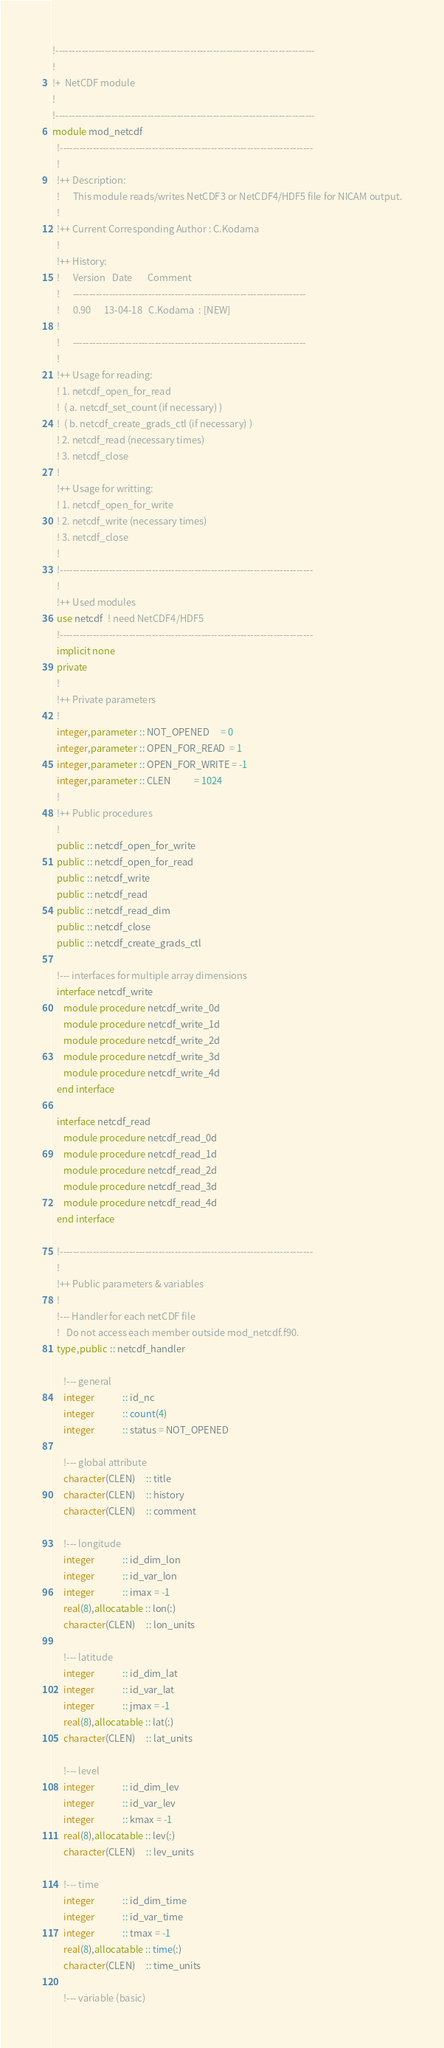Convert code to text. <code><loc_0><loc_0><loc_500><loc_500><_FORTRAN_>!-------------------------------------------------------------------------------
!
!+  NetCDF module
!
!-------------------------------------------------------------------------------
module mod_netcdf
  !-----------------------------------------------------------------------------
  !
  !++ Description: 
  !      This module reads/writes NetCDF3 or NetCDF4/HDF5 file for NICAM output.
  ! 
  !++ Current Corresponding Author : C.Kodama
  ! 
  !++ History: 
  !      Version   Date       Comment 
  !      -----------------------------------------------------------------------
  !      0.90      13-04-18   C.Kodama  : [NEW]
  !
  !      -----------------------------------------------------------------------
  !
  !++ Usage for reading:
  ! 1. netcdf_open_for_read
  !  ( a. netcdf_set_count (if necessary) )
  !  ( b. netcdf_create_grads_ctl (if necessary) )
  ! 2. netcdf_read (necessary times)
  ! 3. netcdf_close
  !
  !++ Usage for writting:
  ! 1. netcdf_open_for_write
  ! 2. netcdf_write (necessary times)
  ! 3. netcdf_close
  !
  !-----------------------------------------------------------------------------
  !
  !++ Used modules
  use netcdf  ! need NetCDF4/HDF5
  !-----------------------------------------------------------------------------
  implicit none
  private
  !
  !++ Private parameters
  !
  integer,parameter :: NOT_OPENED     = 0
  integer,parameter :: OPEN_FOR_READ  = 1
  integer,parameter :: OPEN_FOR_WRITE = -1
  integer,parameter :: CLEN           = 1024
  !
  !++ Public procedures
  !
  public :: netcdf_open_for_write
  public :: netcdf_open_for_read
  public :: netcdf_write
  public :: netcdf_read
  public :: netcdf_read_dim
  public :: netcdf_close
  public :: netcdf_create_grads_ctl

  !--- interfaces for multiple array dimensions
  interface netcdf_write
     module procedure netcdf_write_0d
     module procedure netcdf_write_1d
     module procedure netcdf_write_2d
     module procedure netcdf_write_3d
     module procedure netcdf_write_4d
  end interface

  interface netcdf_read
     module procedure netcdf_read_0d
     module procedure netcdf_read_1d
     module procedure netcdf_read_2d
     module procedure netcdf_read_3d
     module procedure netcdf_read_4d
  end interface

  !-----------------------------------------------------------------------------
  !
  !++ Public parameters & variables
  !
  !--- Handler for each netCDF file
  !   Do not access each member outside mod_netcdf.f90.
  type,public :: netcdf_handler

     !--- general
     integer             :: id_nc
     integer             :: count(4)
     integer             :: status = NOT_OPENED

     !--- global attribute
     character(CLEN)     :: title
     character(CLEN)     :: history
     character(CLEN)     :: comment

     !--- longitude
     integer             :: id_dim_lon
     integer             :: id_var_lon
     integer             :: imax = -1
     real(8),allocatable :: lon(:)
     character(CLEN)     :: lon_units

     !--- latitude
     integer             :: id_dim_lat
     integer             :: id_var_lat
     integer             :: jmax = -1
     real(8),allocatable :: lat(:)
     character(CLEN)     :: lat_units

     !--- level
     integer             :: id_dim_lev
     integer             :: id_var_lev
     integer             :: kmax = -1
     real(8),allocatable :: lev(:)
     character(CLEN)     :: lev_units

     !--- time
     integer             :: id_dim_time
     integer             :: id_var_time
     integer             :: tmax = -1
     real(8),allocatable :: time(:)
     character(CLEN)     :: time_units

     !--- variable (basic)</code> 